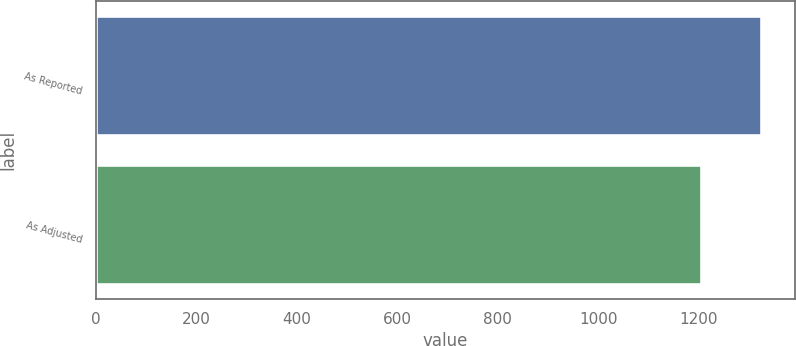Convert chart. <chart><loc_0><loc_0><loc_500><loc_500><bar_chart><fcel>As Reported<fcel>As Adjusted<nl><fcel>1325.1<fcel>1205.1<nl></chart> 